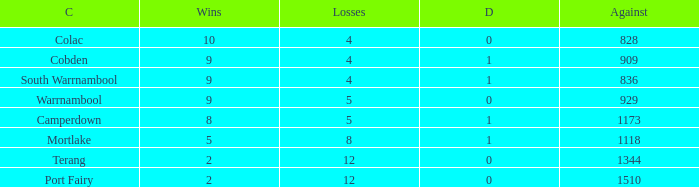What is the total number of Against values for clubs with more than 2 wins, 5 losses, and 0 draws? 0.0. 